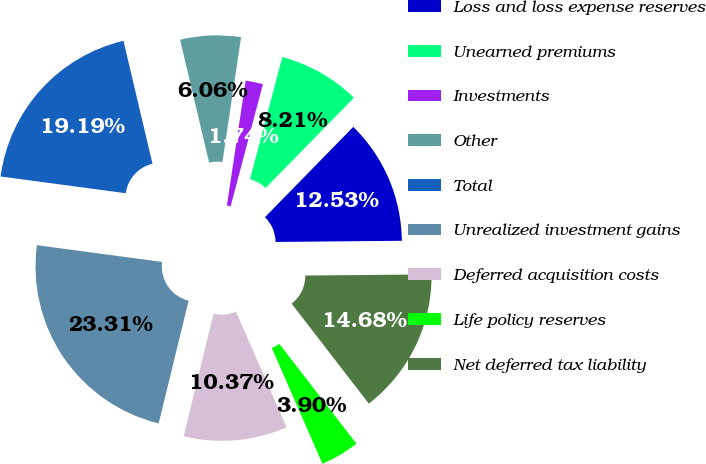Convert chart. <chart><loc_0><loc_0><loc_500><loc_500><pie_chart><fcel>Loss and loss expense reserves<fcel>Unearned premiums<fcel>Investments<fcel>Other<fcel>Total<fcel>Unrealized investment gains<fcel>Deferred acquisition costs<fcel>Life policy reserves<fcel>Net deferred tax liability<nl><fcel>12.53%<fcel>8.21%<fcel>1.74%<fcel>6.06%<fcel>19.19%<fcel>23.31%<fcel>10.37%<fcel>3.9%<fcel>14.68%<nl></chart> 